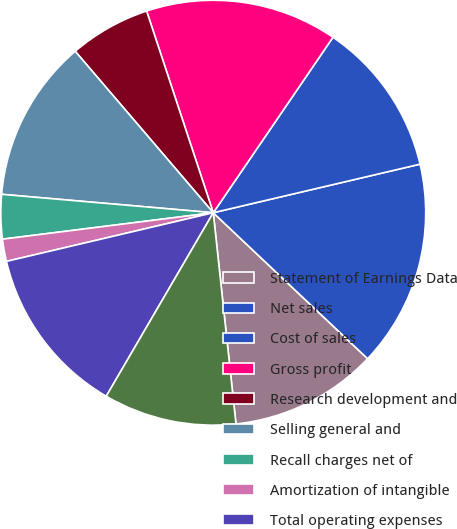<chart> <loc_0><loc_0><loc_500><loc_500><pie_chart><fcel>Statement of Earnings Data<fcel>Net sales<fcel>Cost of sales<fcel>Gross profit<fcel>Research development and<fcel>Selling general and<fcel>Recall charges net of<fcel>Amortization of intangible<fcel>Total operating expenses<fcel>Operating income<nl><fcel>11.24%<fcel>15.73%<fcel>11.8%<fcel>14.61%<fcel>6.18%<fcel>12.36%<fcel>3.37%<fcel>1.69%<fcel>12.92%<fcel>10.11%<nl></chart> 